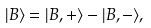<formula> <loc_0><loc_0><loc_500><loc_500>| B \rangle = | B , + \rangle - | B , - \rangle ,</formula> 